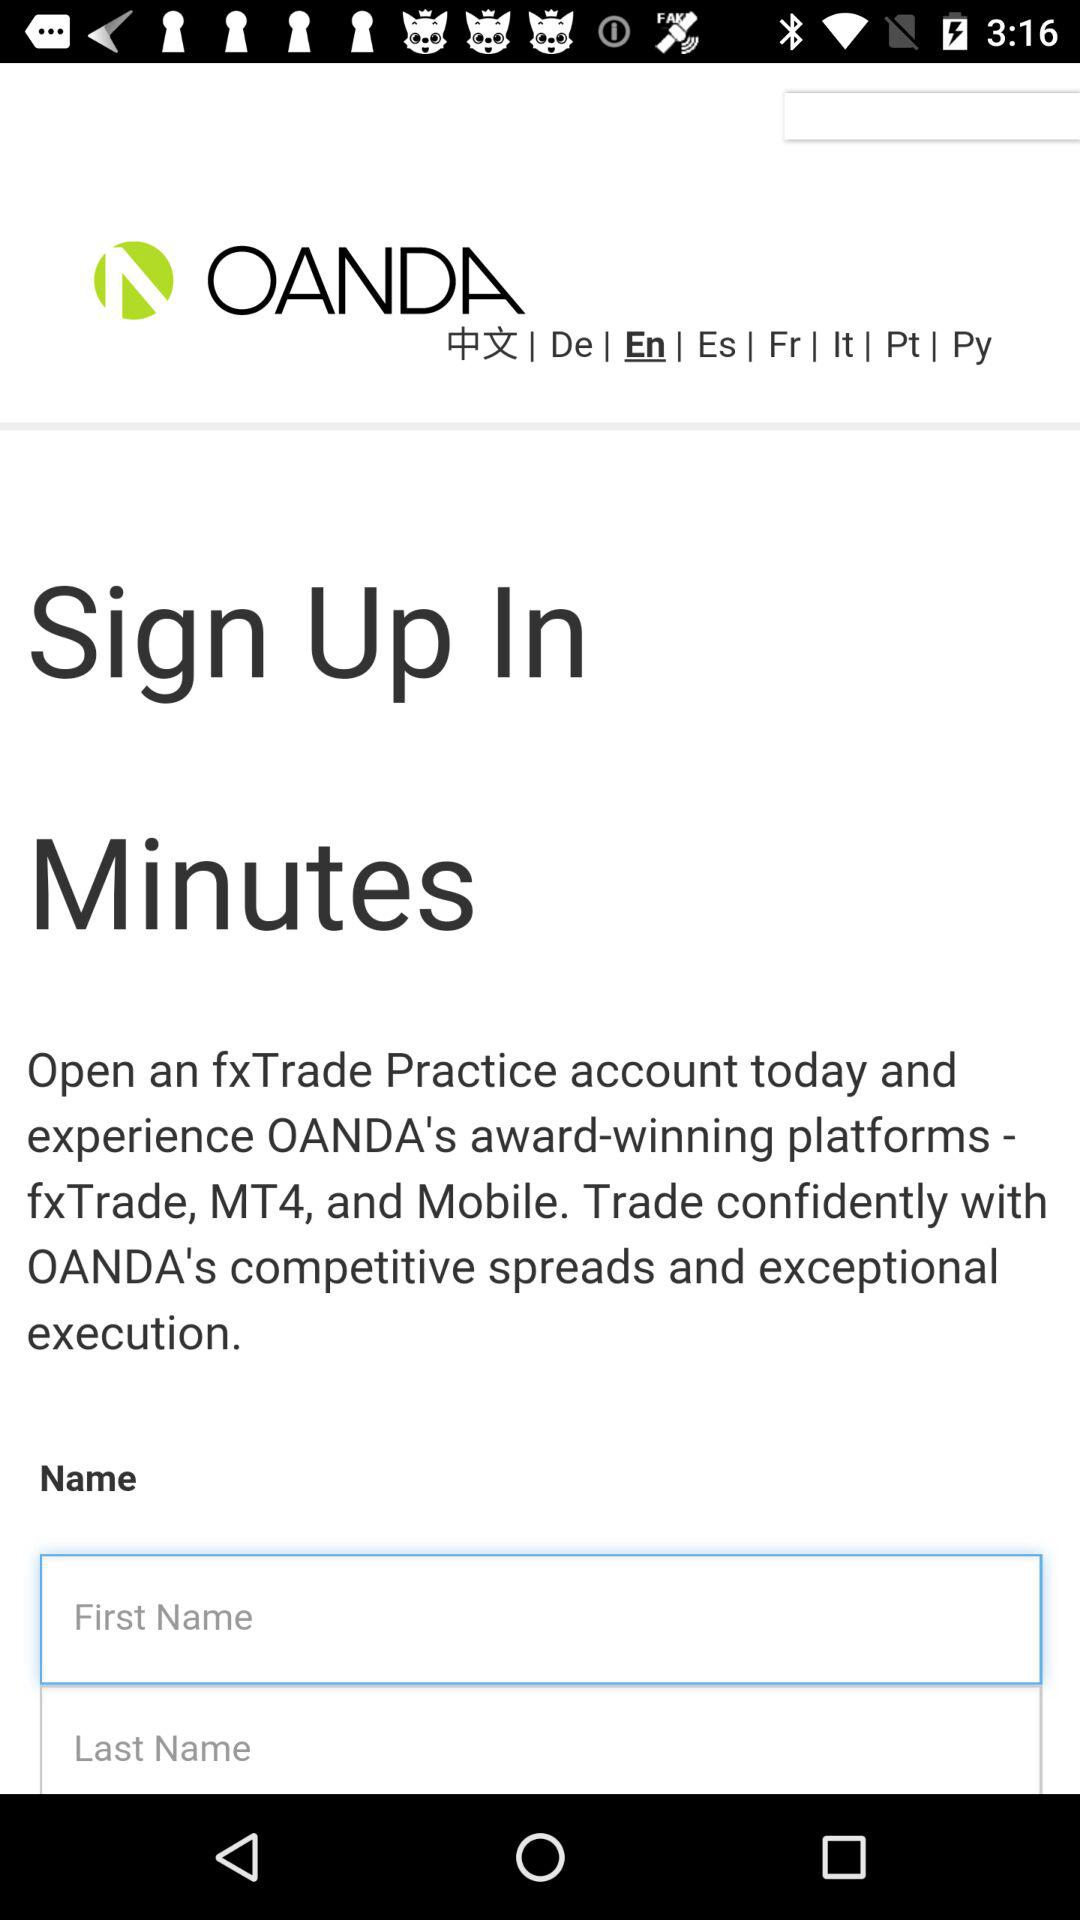Can you tell what languages are supported by the platform displayed in the image? The platform supports multiple languages including Chinese (中文), German (De), English (En), Spanish (Es), French (Fr), Italian (It), Portuguese (Pt), and Russian (Py), as indicated by the language selection options at the top of the image. 